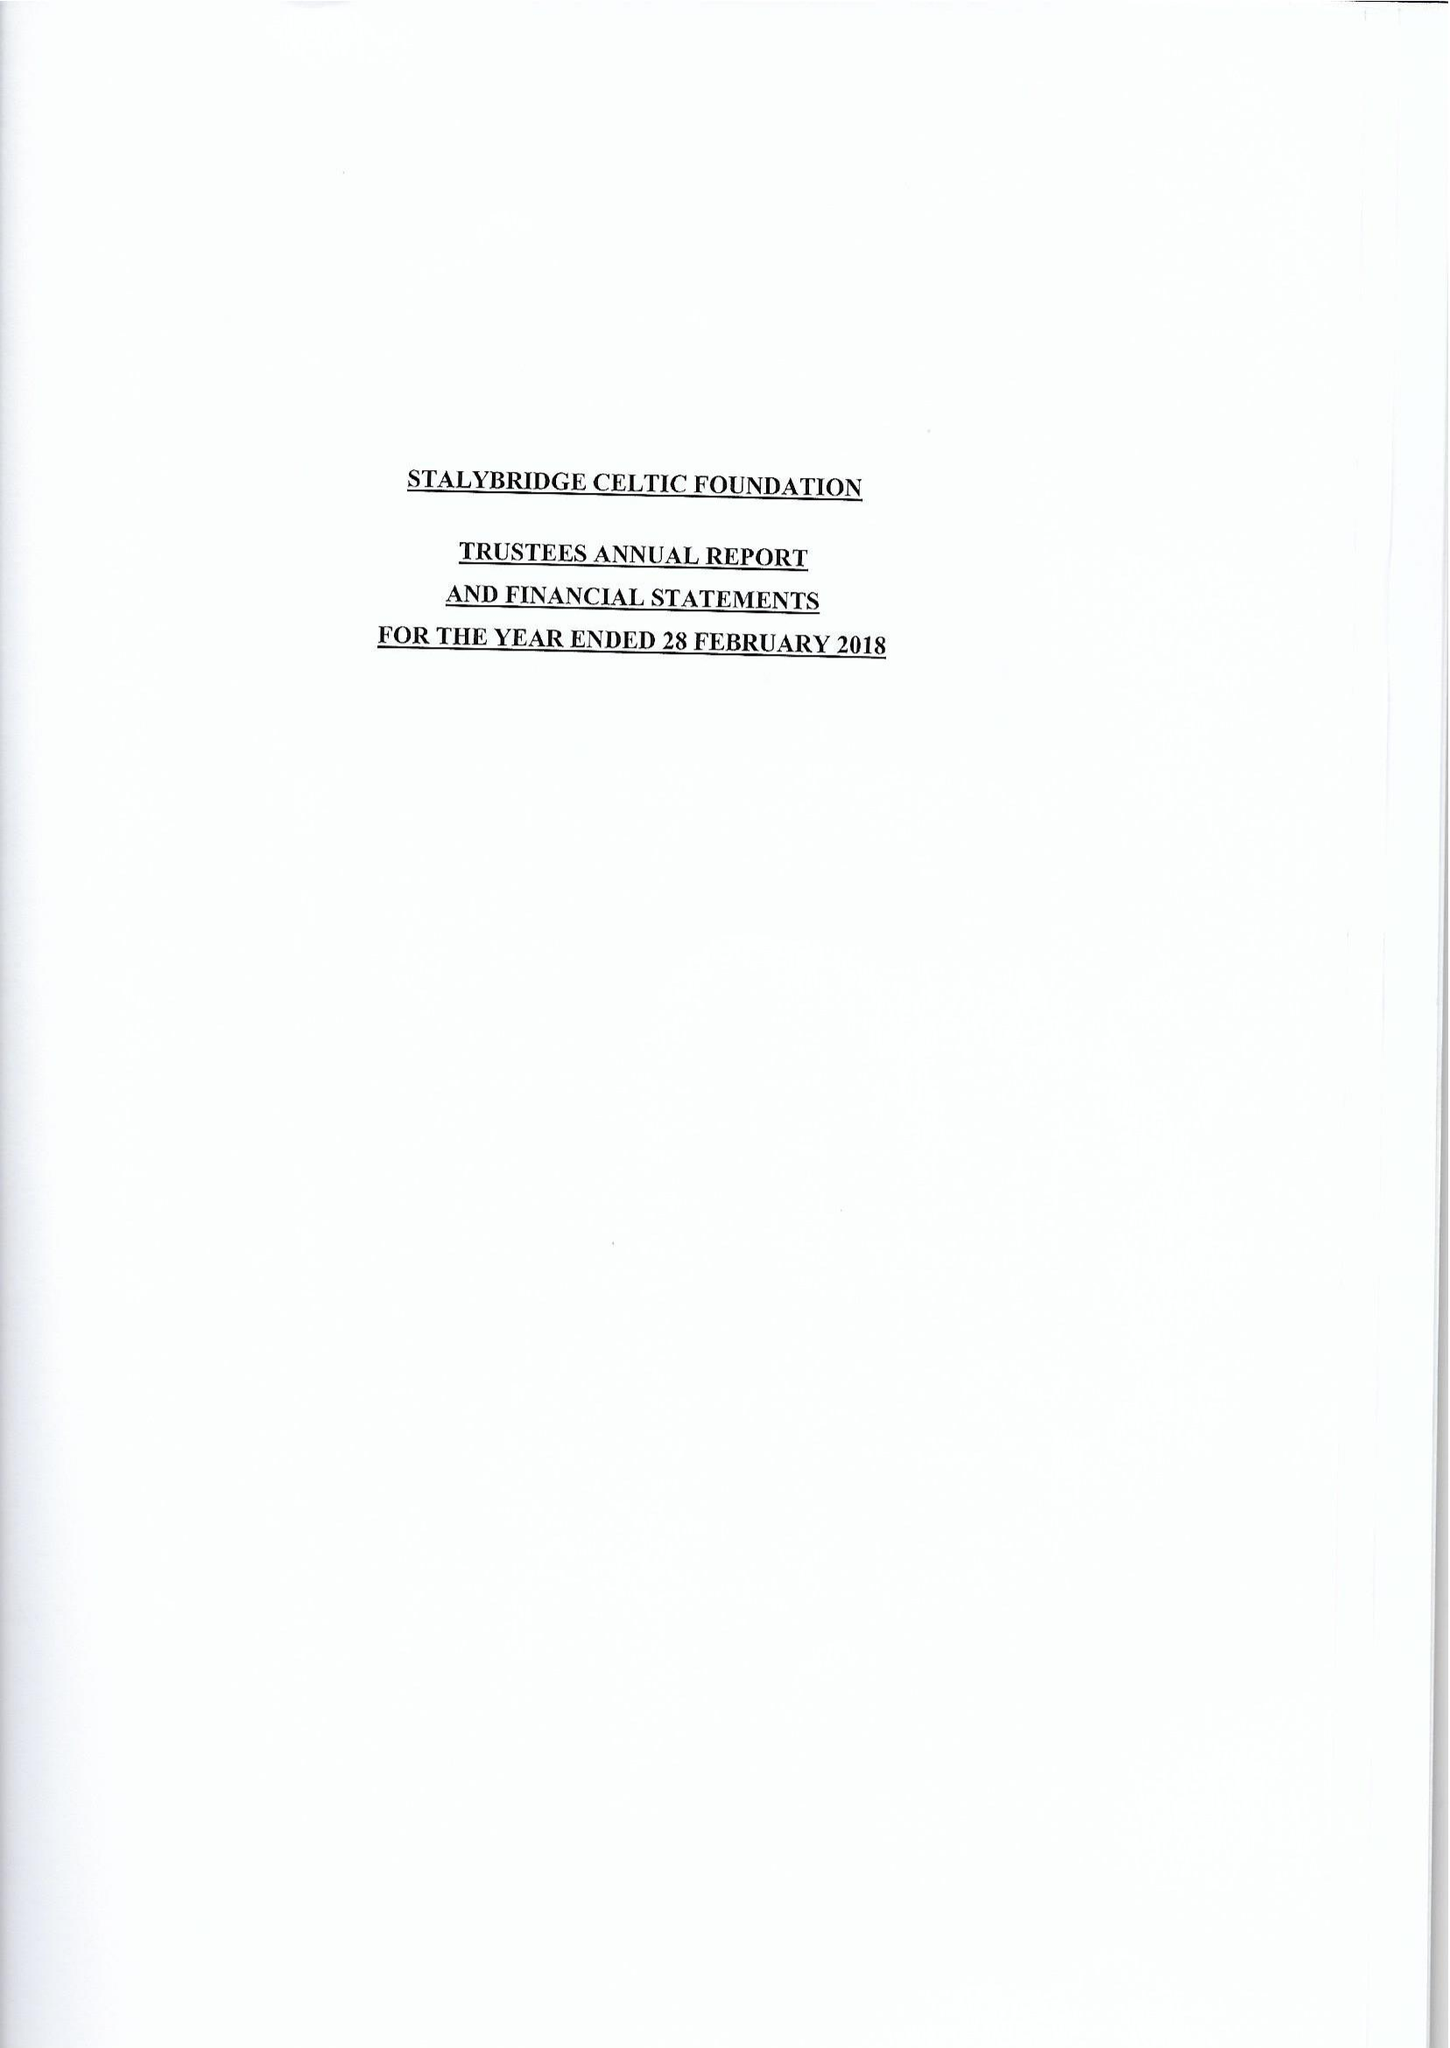What is the value for the address__street_line?
Answer the question using a single word or phrase. MOTTRAM ROAD 